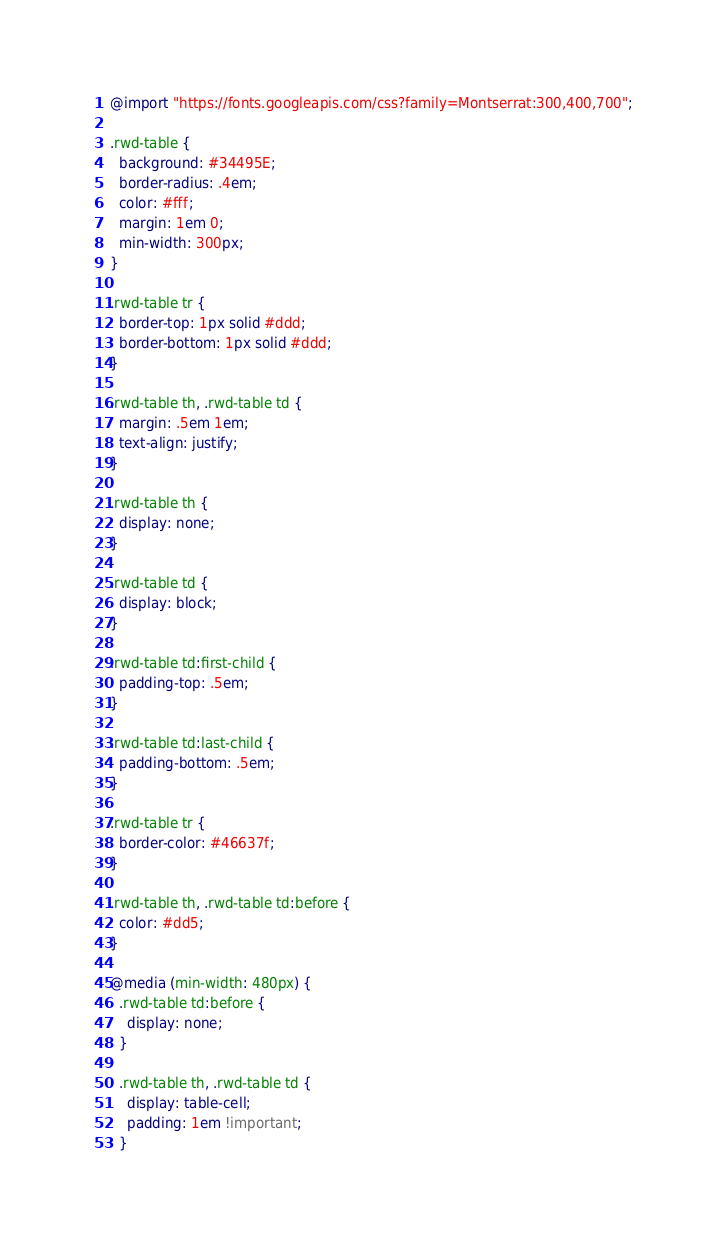<code> <loc_0><loc_0><loc_500><loc_500><_CSS_>@import "https://fonts.googleapis.com/css?family=Montserrat:300,400,700";

.rwd-table {
  background: #34495E;
  border-radius: .4em;
  color: #fff;
  margin: 1em 0;
  min-width: 300px;
}

.rwd-table tr {
  border-top: 1px solid #ddd;
  border-bottom: 1px solid #ddd;
}

.rwd-table th, .rwd-table td {
  margin: .5em 1em;
  text-align: justify;
}

.rwd-table th {
  display: none;
}

.rwd-table td {
  display: block;
}

.rwd-table td:first-child {
  padding-top: .5em;
}

.rwd-table td:last-child {
  padding-bottom: .5em;
}

.rwd-table tr {
  border-color: #46637f;
}

.rwd-table th, .rwd-table td:before {
  color: #dd5;
}

@media (min-width: 480px) {
  .rwd-table td:before {
    display: none;
  }

  .rwd-table th, .rwd-table td {
    display: table-cell;
    padding: 1em !important;
  }
</code> 